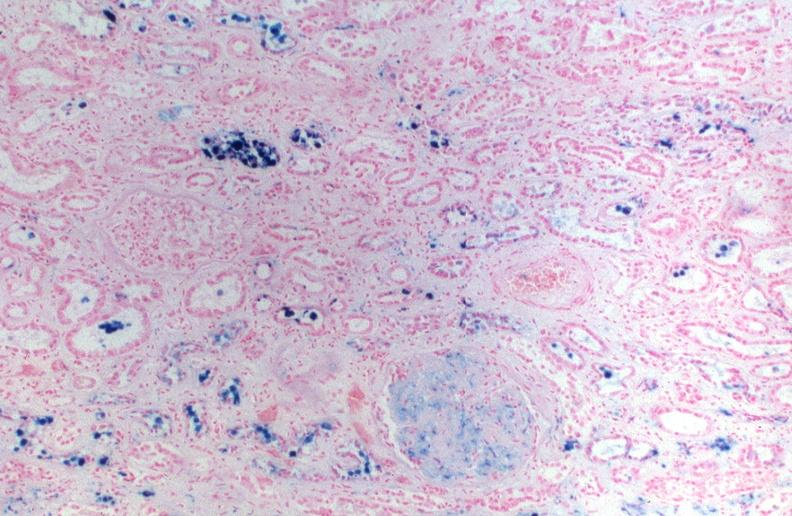where is this?
Answer the question using a single word or phrase. Urinary 